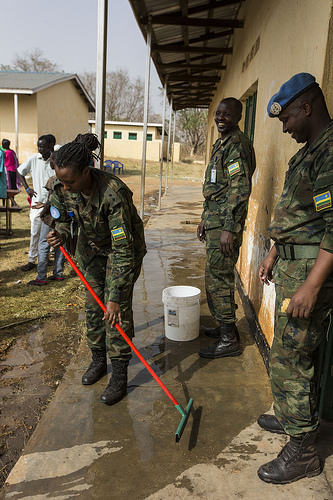<image>
Is there a woman behind the pole? No. The woman is not behind the pole. From this viewpoint, the woman appears to be positioned elsewhere in the scene. 